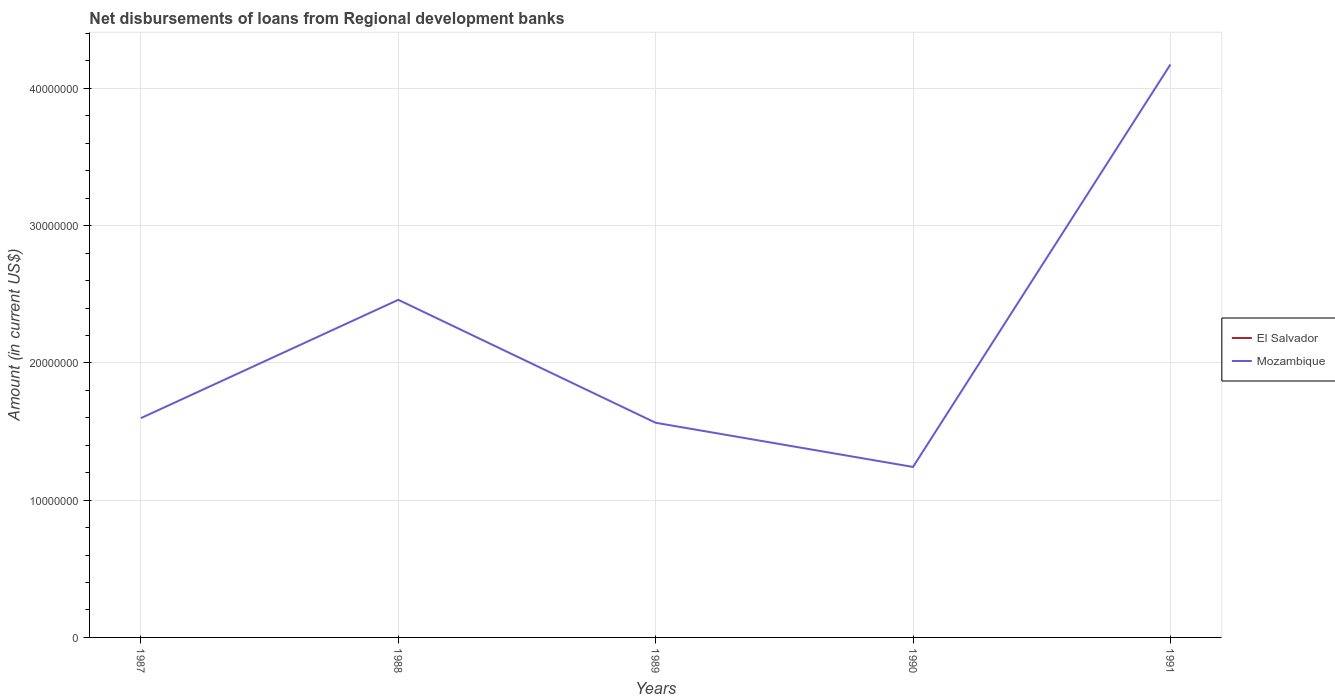How many different coloured lines are there?
Provide a succinct answer. 1. Is the number of lines equal to the number of legend labels?
Offer a terse response. No. Across all years, what is the maximum amount of disbursements of loans from regional development banks in El Salvador?
Keep it short and to the point. 0. What is the total amount of disbursements of loans from regional development banks in Mozambique in the graph?
Offer a terse response. 3.56e+06. What is the difference between the highest and the second highest amount of disbursements of loans from regional development banks in Mozambique?
Ensure brevity in your answer.  2.93e+07. What is the difference between the highest and the lowest amount of disbursements of loans from regional development banks in Mozambique?
Keep it short and to the point. 2. Is the amount of disbursements of loans from regional development banks in Mozambique strictly greater than the amount of disbursements of loans from regional development banks in El Salvador over the years?
Offer a very short reply. No. How many years are there in the graph?
Ensure brevity in your answer.  5. Are the values on the major ticks of Y-axis written in scientific E-notation?
Ensure brevity in your answer.  No. How are the legend labels stacked?
Ensure brevity in your answer.  Vertical. What is the title of the graph?
Provide a short and direct response. Net disbursements of loans from Regional development banks. What is the label or title of the Y-axis?
Provide a succinct answer. Amount (in current US$). What is the Amount (in current US$) in Mozambique in 1987?
Make the answer very short. 1.60e+07. What is the Amount (in current US$) in El Salvador in 1988?
Offer a very short reply. 0. What is the Amount (in current US$) in Mozambique in 1988?
Ensure brevity in your answer.  2.46e+07. What is the Amount (in current US$) of Mozambique in 1989?
Your answer should be very brief. 1.56e+07. What is the Amount (in current US$) in Mozambique in 1990?
Your answer should be compact. 1.24e+07. What is the Amount (in current US$) in Mozambique in 1991?
Provide a succinct answer. 4.17e+07. Across all years, what is the maximum Amount (in current US$) of Mozambique?
Your answer should be compact. 4.17e+07. Across all years, what is the minimum Amount (in current US$) in Mozambique?
Your answer should be very brief. 1.24e+07. What is the total Amount (in current US$) of Mozambique in the graph?
Your answer should be compact. 1.10e+08. What is the difference between the Amount (in current US$) of Mozambique in 1987 and that in 1988?
Your answer should be compact. -8.62e+06. What is the difference between the Amount (in current US$) of Mozambique in 1987 and that in 1990?
Ensure brevity in your answer.  3.56e+06. What is the difference between the Amount (in current US$) in Mozambique in 1987 and that in 1991?
Your answer should be very brief. -2.58e+07. What is the difference between the Amount (in current US$) in Mozambique in 1988 and that in 1989?
Provide a short and direct response. 8.96e+06. What is the difference between the Amount (in current US$) in Mozambique in 1988 and that in 1990?
Keep it short and to the point. 1.22e+07. What is the difference between the Amount (in current US$) of Mozambique in 1988 and that in 1991?
Keep it short and to the point. -1.71e+07. What is the difference between the Amount (in current US$) of Mozambique in 1989 and that in 1990?
Your response must be concise. 3.22e+06. What is the difference between the Amount (in current US$) of Mozambique in 1989 and that in 1991?
Make the answer very short. -2.61e+07. What is the difference between the Amount (in current US$) of Mozambique in 1990 and that in 1991?
Provide a succinct answer. -2.93e+07. What is the average Amount (in current US$) in El Salvador per year?
Your response must be concise. 0. What is the average Amount (in current US$) in Mozambique per year?
Your response must be concise. 2.21e+07. What is the ratio of the Amount (in current US$) in Mozambique in 1987 to that in 1988?
Your answer should be compact. 0.65. What is the ratio of the Amount (in current US$) of Mozambique in 1987 to that in 1989?
Ensure brevity in your answer.  1.02. What is the ratio of the Amount (in current US$) of Mozambique in 1987 to that in 1990?
Make the answer very short. 1.29. What is the ratio of the Amount (in current US$) of Mozambique in 1987 to that in 1991?
Keep it short and to the point. 0.38. What is the ratio of the Amount (in current US$) of Mozambique in 1988 to that in 1989?
Provide a succinct answer. 1.57. What is the ratio of the Amount (in current US$) of Mozambique in 1988 to that in 1990?
Offer a terse response. 1.98. What is the ratio of the Amount (in current US$) of Mozambique in 1988 to that in 1991?
Your answer should be compact. 0.59. What is the ratio of the Amount (in current US$) of Mozambique in 1989 to that in 1990?
Offer a very short reply. 1.26. What is the ratio of the Amount (in current US$) of Mozambique in 1989 to that in 1991?
Offer a terse response. 0.37. What is the ratio of the Amount (in current US$) in Mozambique in 1990 to that in 1991?
Keep it short and to the point. 0.3. What is the difference between the highest and the second highest Amount (in current US$) in Mozambique?
Keep it short and to the point. 1.71e+07. What is the difference between the highest and the lowest Amount (in current US$) of Mozambique?
Give a very brief answer. 2.93e+07. 